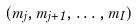<formula> <loc_0><loc_0><loc_500><loc_500>( m _ { j } , m _ { j + 1 } , \dots , m _ { I } )</formula> 